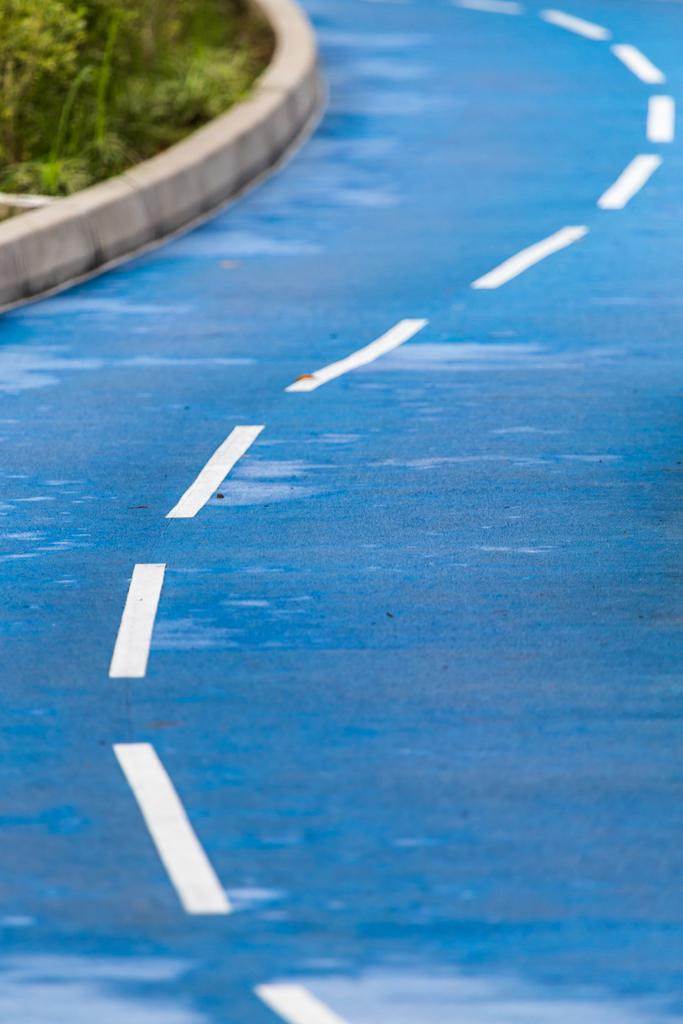What is the main feature in the foreground of the image? There is a road in the foreground of the image. Can you describe any other elements visible in the image? Yes, there are plants visible in the top left of the image. What type of silk can be seen draped over the car in the image? There is no car or silk present in the image. How many eggs are visible on the plants in the image? There are no eggs visible on the plants in the image. 